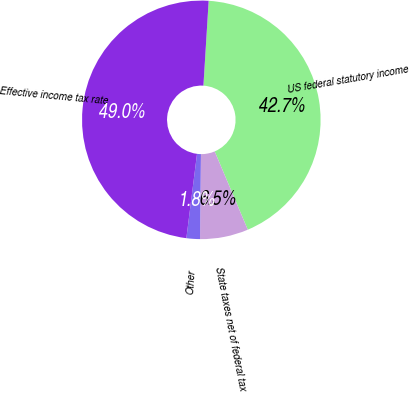Convert chart. <chart><loc_0><loc_0><loc_500><loc_500><pie_chart><fcel>US federal statutory income<fcel>State taxes net of federal tax<fcel>Other<fcel>Effective income tax rate<nl><fcel>42.65%<fcel>6.54%<fcel>1.83%<fcel>48.98%<nl></chart> 